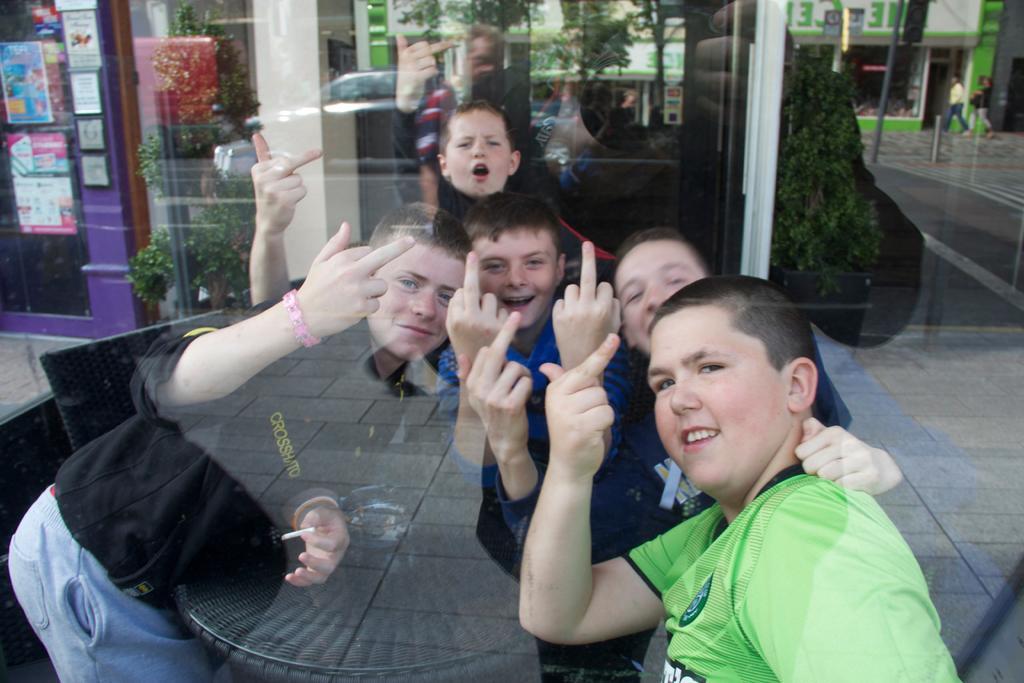How would you summarize this image in a sentence or two? In this image we can see the boys showing the fingers. We can also see a table, chairs, bowl and also the trees, plant, vehicle, posters, people, light pole and also the building through the glass. We can also see the road. 